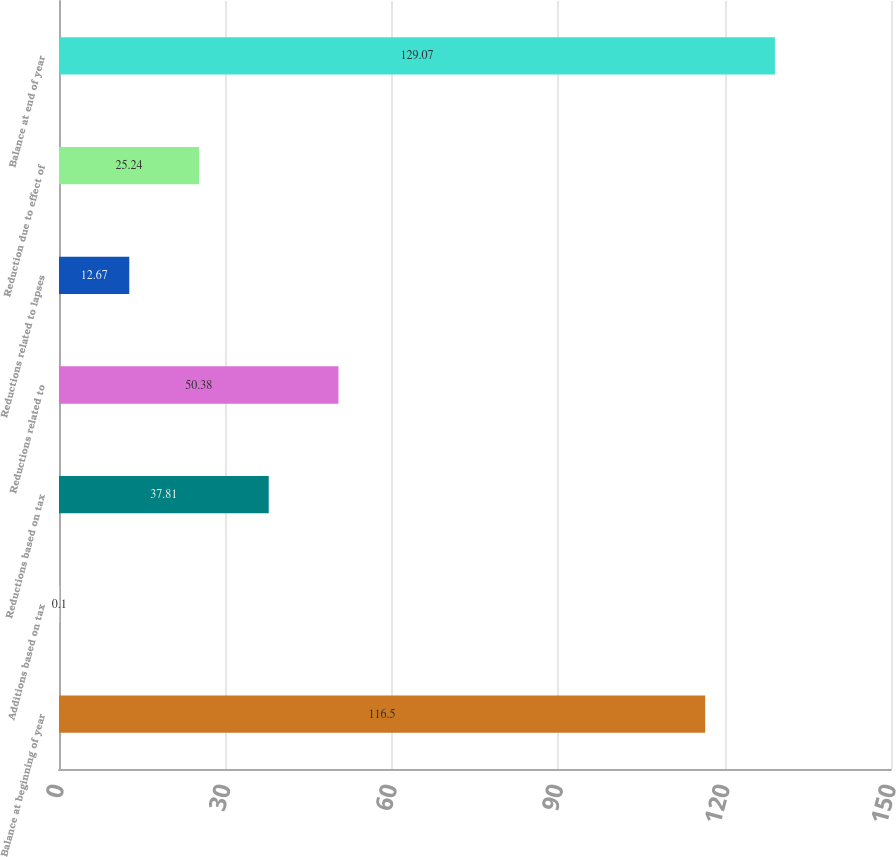Convert chart to OTSL. <chart><loc_0><loc_0><loc_500><loc_500><bar_chart><fcel>Balance at beginning of year<fcel>Additions based on tax<fcel>Reductions based on tax<fcel>Reductions related to<fcel>Reductions related to lapses<fcel>Reduction due to effect of<fcel>Balance at end of year<nl><fcel>116.5<fcel>0.1<fcel>37.81<fcel>50.38<fcel>12.67<fcel>25.24<fcel>129.07<nl></chart> 